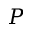Convert formula to latex. <formula><loc_0><loc_0><loc_500><loc_500>P</formula> 